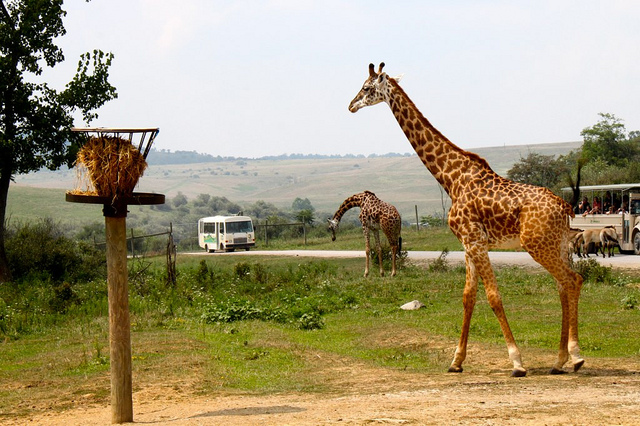What types of animals can be seen in the image, and what does their presence suggest about the location? The image shows giraffes, which are native to the savannahs and open woodlands of Africa. Their presence suggests that the location is likely a wildlife reserve or a natural park in Africa, designed to preserve and showcase native wildlife in their natural environment. 